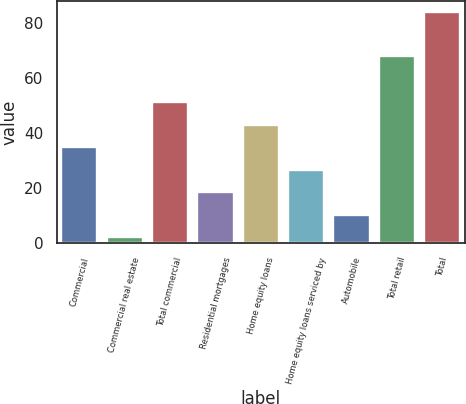Convert chart. <chart><loc_0><loc_0><loc_500><loc_500><bar_chart><fcel>Commercial<fcel>Commercial real estate<fcel>Total commercial<fcel>Residential mortgages<fcel>Home equity loans<fcel>Home equity loans serviced by<fcel>Automobile<fcel>Total retail<fcel>Total<nl><fcel>34.8<fcel>2<fcel>51.2<fcel>18.4<fcel>43<fcel>26.6<fcel>10.2<fcel>68<fcel>84<nl></chart> 